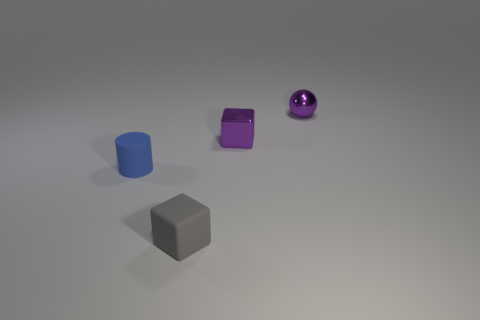Add 2 tiny blocks. How many objects exist? 6 Subtract all cylinders. How many objects are left? 3 Add 4 purple metal blocks. How many purple metal blocks are left? 5 Add 4 tiny metal things. How many tiny metal things exist? 6 Subtract 0 green spheres. How many objects are left? 4 Subtract all small cubes. Subtract all tiny purple objects. How many objects are left? 0 